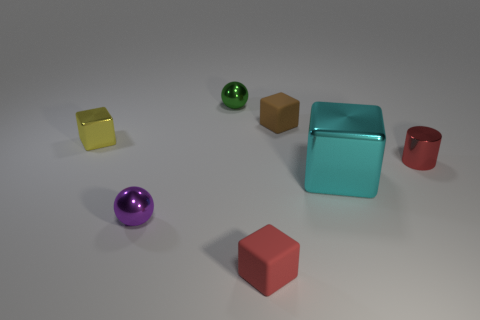Is the number of green shiny objects that are on the right side of the green sphere less than the number of small yellow blocks?
Provide a short and direct response. Yes. What number of rubber blocks have the same color as the big metal thing?
Offer a terse response. 0. What material is the tiny object that is both on the left side of the red rubber object and on the right side of the purple metal object?
Offer a terse response. Metal. There is a rubber object in front of the big cyan shiny cube; does it have the same color as the tiny thing right of the cyan shiny block?
Offer a very short reply. Yes. What number of gray things are either tiny shiny cylinders or tiny matte cubes?
Keep it short and to the point. 0. Are there fewer small yellow objects on the right side of the tiny shiny cylinder than small blocks that are to the right of the tiny purple thing?
Offer a very short reply. Yes. Are there any shiny spheres that have the same size as the brown cube?
Keep it short and to the point. Yes. Does the red object that is in front of the red metal thing have the same size as the cyan object?
Offer a terse response. No. Are there more big cyan metallic objects than big red rubber cylinders?
Give a very brief answer. Yes. Is there another tiny rubber thing of the same shape as the small purple object?
Give a very brief answer. No. 